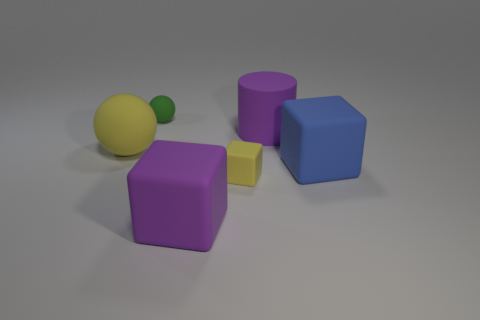How many of the objects in the image have both flat surfaces and straight edges? In the image, there are four objects with both flat surfaces and straight edges: the yellow cube, the purple cube, the blue cube, and the purple cylinder.  Can you identify any symmetrical objects? Yes, the yellow and green spheres show radial symmetry, while the cubes and the cylinder exhibit bilateral symmetry about multiple planes. 